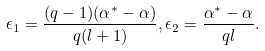Convert formula to latex. <formula><loc_0><loc_0><loc_500><loc_500>\epsilon _ { 1 } = \frac { ( q - 1 ) ( \alpha ^ { * } - \alpha ) } { q ( l + 1 ) } , \epsilon _ { 2 } = \frac { \alpha ^ { * } - \alpha } { q l } .</formula> 